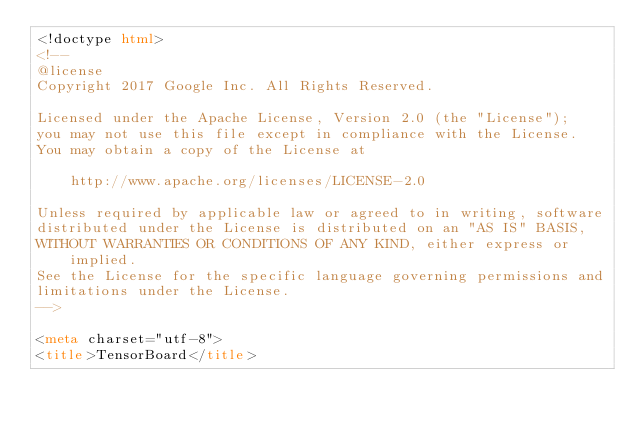<code> <loc_0><loc_0><loc_500><loc_500><_HTML_><!doctype html>
<!--
@license
Copyright 2017 Google Inc. All Rights Reserved.

Licensed under the Apache License, Version 2.0 (the "License");
you may not use this file except in compliance with the License.
You may obtain a copy of the License at

    http://www.apache.org/licenses/LICENSE-2.0

Unless required by applicable law or agreed to in writing, software
distributed under the License is distributed on an "AS IS" BASIS,
WITHOUT WARRANTIES OR CONDITIONS OF ANY KIND, either express or implied.
See the License for the specific language governing permissions and
limitations under the License.
-->

<meta charset="utf-8">
<title>TensorBoard</title></code> 